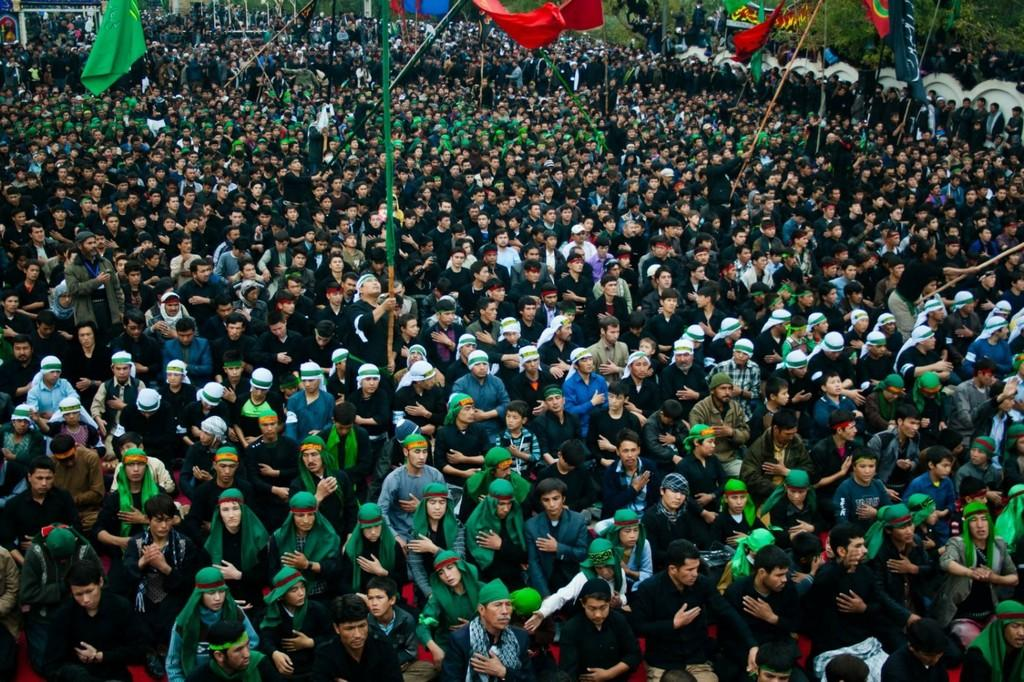How many people are in the image? There is a group of people in the image. What are the people wearing on their heads? The people are wearing headscarves. What can be seen in the image besides the people? There are poles and flags in the image. What is visible in the background of the image? There are trees, buildings, poles, and ropes in the background of the image. How many deer are visible in the image? There are no deer present in the image. What type of system is being used to organize the flags in the image? There is no system mentioned or visible in the image for organizing the flags. 